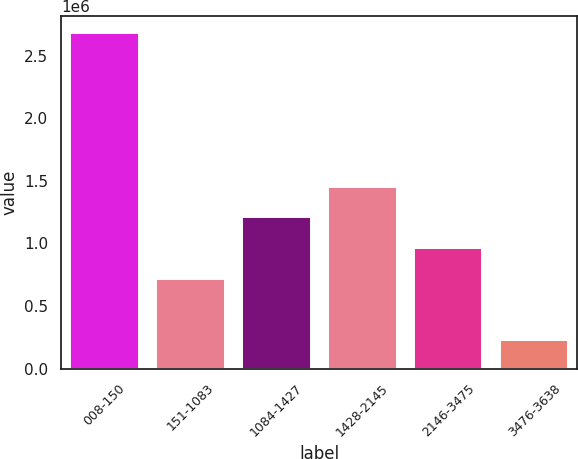Convert chart. <chart><loc_0><loc_0><loc_500><loc_500><bar_chart><fcel>008-150<fcel>151-1083<fcel>1084-1427<fcel>1428-2145<fcel>2146-3475<fcel>3476-3638<nl><fcel>2.68083e+06<fcel>717346<fcel>1.2085e+06<fcel>1.45407e+06<fcel>962922<fcel>225064<nl></chart> 